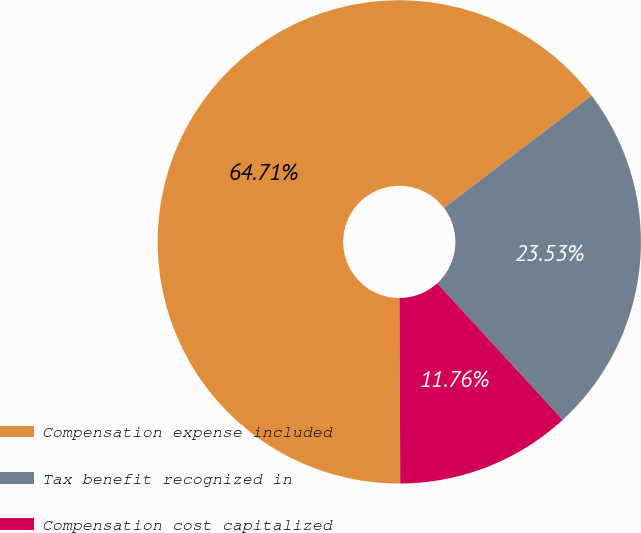Convert chart. <chart><loc_0><loc_0><loc_500><loc_500><pie_chart><fcel>Compensation expense included<fcel>Tax benefit recognized in<fcel>Compensation cost capitalized<nl><fcel>64.71%<fcel>23.53%<fcel>11.76%<nl></chart> 